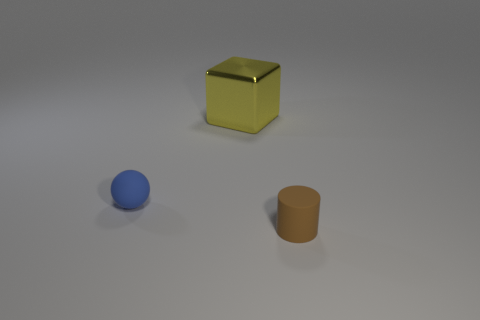There is a yellow metallic block; are there any objects on the left side of it?
Your answer should be compact. Yes. How many rubber things are red cylinders or large yellow objects?
Make the answer very short. 0. There is a cube; how many yellow metallic objects are left of it?
Ensure brevity in your answer.  0. Are there any other matte spheres of the same size as the matte ball?
Ensure brevity in your answer.  No. Is there anything else that has the same size as the metallic thing?
Offer a terse response. No. There is a block; is it the same color as the matte thing in front of the blue matte thing?
Offer a very short reply. No. How many objects are brown rubber cylinders or tiny matte objects that are behind the brown rubber cylinder?
Provide a succinct answer. 2. There is a thing behind the matte thing that is to the left of the brown matte cylinder; how big is it?
Your answer should be compact. Large. Are there the same number of small blue things right of the large block and small matte things that are in front of the rubber ball?
Your answer should be compact. No. There is a tiny object to the right of the ball; are there any tiny objects behind it?
Provide a succinct answer. Yes. 